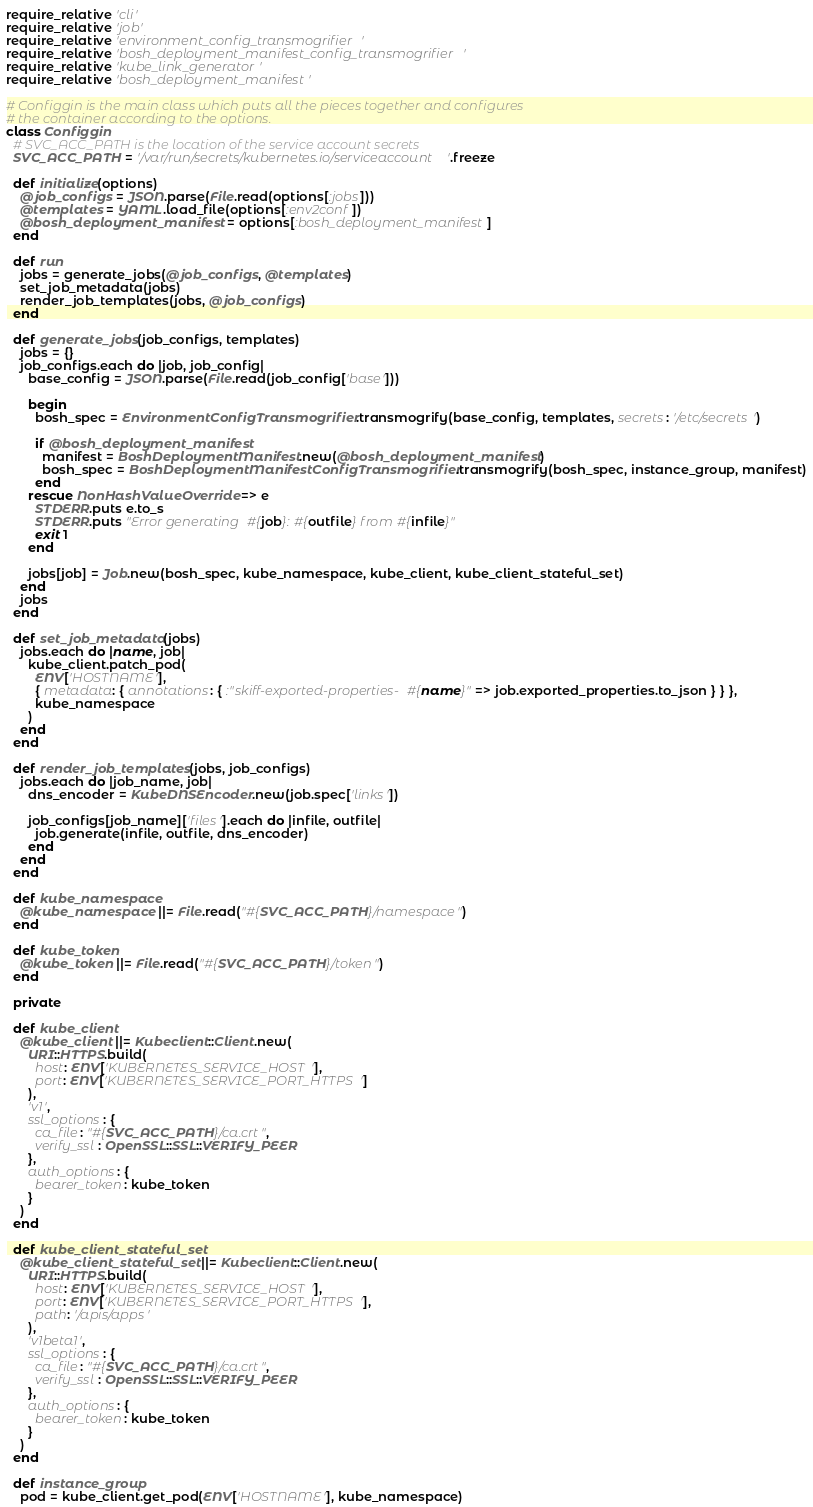Convert code to text. <code><loc_0><loc_0><loc_500><loc_500><_Ruby_>require_relative 'cli'
require_relative 'job'
require_relative 'environment_config_transmogrifier'
require_relative 'bosh_deployment_manifest_config_transmogrifier'
require_relative 'kube_link_generator'
require_relative 'bosh_deployment_manifest'

# Configgin is the main class which puts all the pieces together and configures
# the container according to the options.
class Configgin
  # SVC_ACC_PATH is the location of the service account secrets
  SVC_ACC_PATH = '/var/run/secrets/kubernetes.io/serviceaccount'.freeze

  def initialize(options)
    @job_configs = JSON.parse(File.read(options[:jobs]))
    @templates = YAML.load_file(options[:env2conf])
    @bosh_deployment_manifest = options[:bosh_deployment_manifest]
  end

  def run
    jobs = generate_jobs(@job_configs, @templates)
    set_job_metadata(jobs)
    render_job_templates(jobs, @job_configs)
  end

  def generate_jobs(job_configs, templates)
    jobs = {}
    job_configs.each do |job, job_config|
      base_config = JSON.parse(File.read(job_config['base']))

      begin
        bosh_spec = EnvironmentConfigTransmogrifier.transmogrify(base_config, templates, secrets: '/etc/secrets')

        if @bosh_deployment_manifest
          manifest = BoshDeploymentManifest.new(@bosh_deployment_manifest)
          bosh_spec = BoshDeploymentManifestConfigTransmogrifier.transmogrify(bosh_spec, instance_group, manifest)
        end
      rescue NonHashValueOverride => e
        STDERR.puts e.to_s
        STDERR.puts "Error generating #{job}: #{outfile} from #{infile}"
        exit 1
      end

      jobs[job] = Job.new(bosh_spec, kube_namespace, kube_client, kube_client_stateful_set)
    end
    jobs
  end

  def set_job_metadata(jobs)
    jobs.each do |name, job|
      kube_client.patch_pod(
        ENV['HOSTNAME'],
        { metadata: { annotations: { :"skiff-exported-properties-#{name}" => job.exported_properties.to_json } } },
        kube_namespace
      )
    end
  end

  def render_job_templates(jobs, job_configs)
    jobs.each do |job_name, job|
      dns_encoder = KubeDNSEncoder.new(job.spec['links'])

      job_configs[job_name]['files'].each do |infile, outfile|
        job.generate(infile, outfile, dns_encoder)
      end
    end
  end

  def kube_namespace
    @kube_namespace ||= File.read("#{SVC_ACC_PATH}/namespace")
  end

  def kube_token
    @kube_token ||= File.read("#{SVC_ACC_PATH}/token")
  end

  private

  def kube_client
    @kube_client ||= Kubeclient::Client.new(
      URI::HTTPS.build(
        host: ENV['KUBERNETES_SERVICE_HOST'],
        port: ENV['KUBERNETES_SERVICE_PORT_HTTPS']
      ),
      'v1',
      ssl_options: {
        ca_file: "#{SVC_ACC_PATH}/ca.crt",
        verify_ssl: OpenSSL::SSL::VERIFY_PEER
      },
      auth_options: {
        bearer_token: kube_token
      }
    )
  end

  def kube_client_stateful_set
    @kube_client_stateful_set ||= Kubeclient::Client.new(
      URI::HTTPS.build(
        host: ENV['KUBERNETES_SERVICE_HOST'],
        port: ENV['KUBERNETES_SERVICE_PORT_HTTPS'],
        path: '/apis/apps'
      ),
      'v1beta1',
      ssl_options: {
        ca_file: "#{SVC_ACC_PATH}/ca.crt",
        verify_ssl: OpenSSL::SSL::VERIFY_PEER
      },
      auth_options: {
        bearer_token: kube_token
      }
    )
  end

  def instance_group
    pod = kube_client.get_pod(ENV['HOSTNAME'], kube_namespace)</code> 